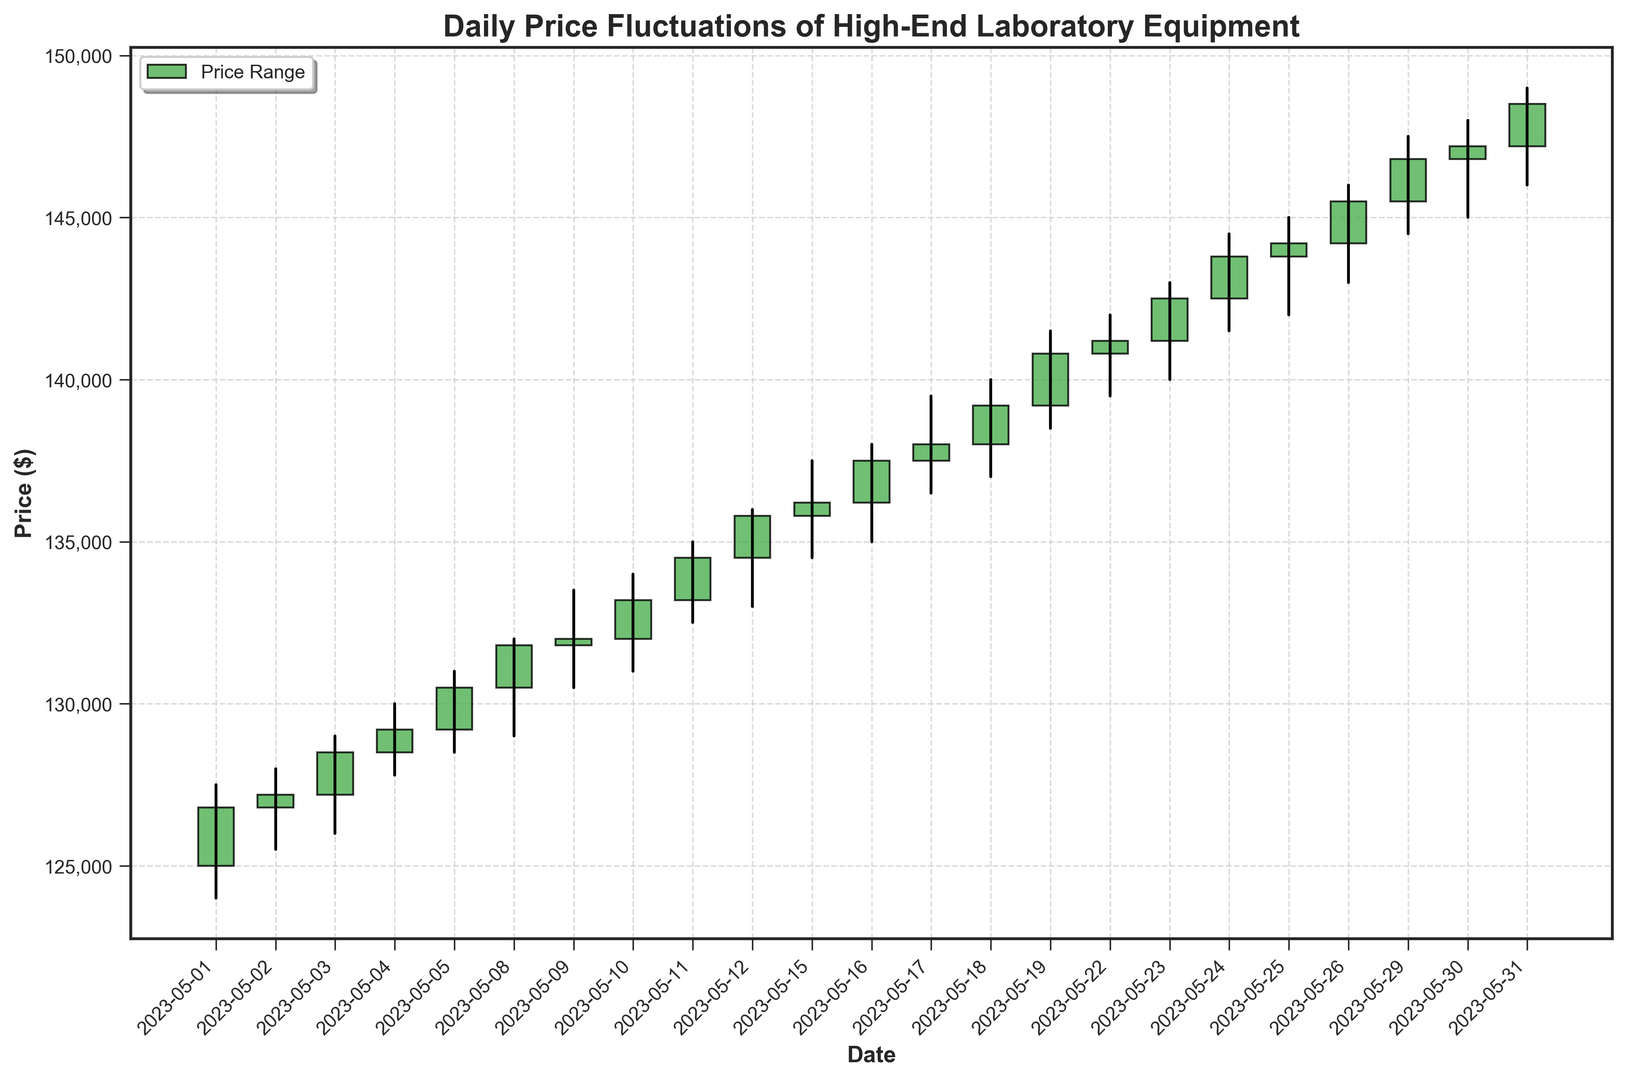Which date has the highest closing price? To find the date with the highest closing price, locate the highest ending point of the candlesticks. The highest close of $148,500 appears on 2023-05-31.
Answer: 2023-05-31 Which date has the lowest opening price? Look at the beginning of the candlesticks to identify the lowest open. The lowest open of $125,000 is on 2023-05-01.
Answer: 2023-05-01 What was the longest candlestick (i.e., greatest difference between open and close)? Assess the height of each candlestick to see which has the greatest vertical distance. The candlestick on 2023-05-03 has the highest difference of $1,300 (close: $128,500 - open: $127,200).
Answer: 2023-05-03 Which two consecutive days had the highest increase in closing price? Check the closing prices from one day to the next and find the highest increase in closing price. The greatest increase in closing price of $1,300 occurred between 2023-05-10 ($133,200) and 2023-05-11 ($134,500).
Answer: 2023-05-10 and 2023-05-11 What was the average closing price over the month? Calculate the sum of all closing prices and divide by the total number of days. Sum of closing prices is $3,979,400, and there are 21 days: $3,979,400 / 21 = $189,495.
Answer: $189,495 Which day saw the greatest intraday price range (i.e., difference between high and low price)? Identify the largest difference between high and low prices from the chart. The greatest range is $3,000 on 2023-05-19 (high: $141,500 - low: $138,500).
Answer: 2023-05-19 Did the closing price ever equal the opening price on any day? Inspect if any candlestick has no body (open = close). None of the candlesticks show open and close being equal.
Answer: No What color represents days where the closing price is greater than the opening price? The color of the candlesticks with a close higher than the open is green.
Answer: Green How many days had a closing price lower than the opening price? Count the red candlesticks (close < open). There were three red candlesticks: 2023-05-01, 2023-05-10, and 2023-05-22.
Answer: 3 days Which day observed the highest wick (price movement within the day from low to high)? Look for the candlestick with the longest line extending above and below it. The highest wick is on 2023-05-31, having a wick of $3,000 (high: $149,000 - low: $146,000).
Answer: 2023-05-31 